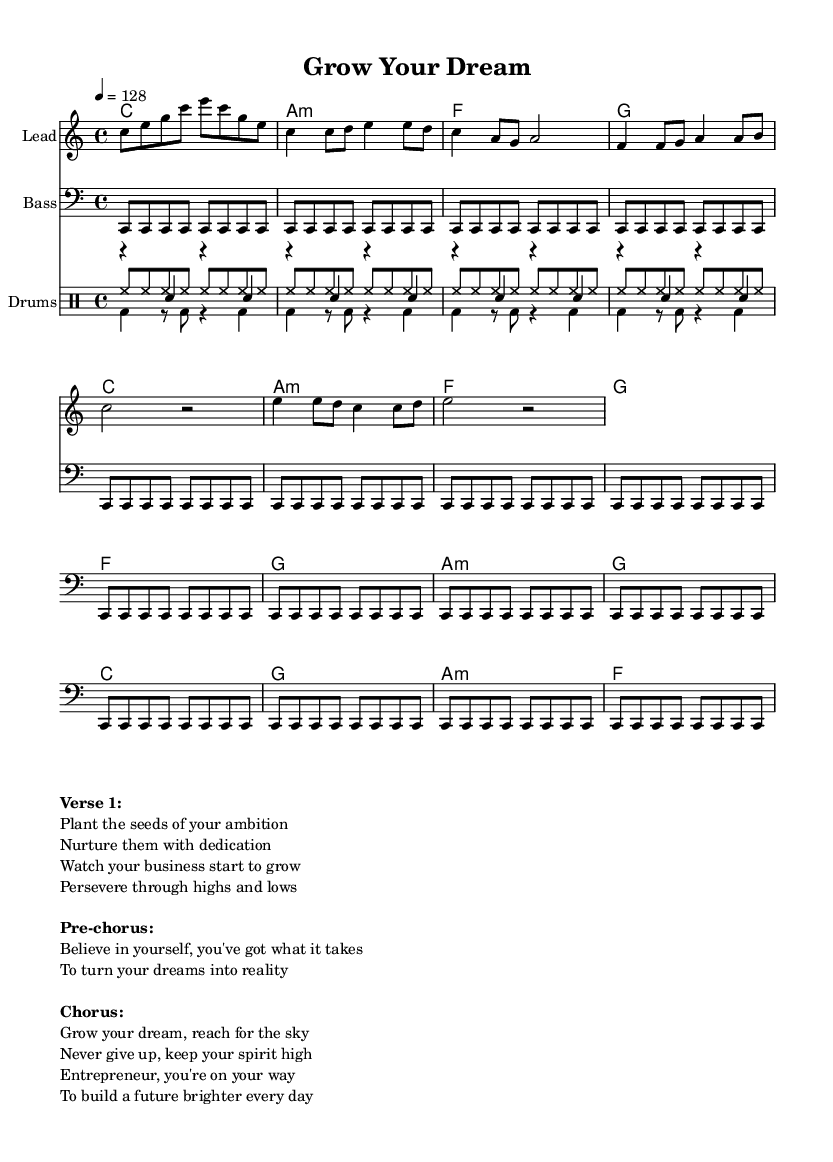What is the key signature of this music? The key signature is indicated as C major, which is shown at the beginning of the score with no sharps or flats.
Answer: C major What is the time signature of this piece? The time signature is displayed at the beginning of the music as 4/4, meaning there are four beats in each measure and a quarter note receives one beat.
Answer: 4/4 What is the tempo marking for this piece? The tempo marking is written as "4 = 128," indicating that there should be 128 beats per minute with a quarter note.
Answer: 128 How many measures are in the chorus? The chorus section consists of four measures, as seen from the notation in that specific section of the score.
Answer: 4 Which chord follows the A minor chord in the harmony? The chord progression shows that the A minor chord is followed by an F major chord in the sequence of the music.
Answer: F What is the structure of the song based on the sections provided? The structure is organized into three main sections: Verse, Pre-chorus, and Chorus, carefully labeled in the markup below the score, showing the flow of the song.
Answer: Verse, Pre-chorus, Chorus How many times does the bass note repeat in the section provided? The bass note is indicated to repeat a total of 16 times in the sheet music, as specified by the repeat instruction in the bass part.
Answer: 16 